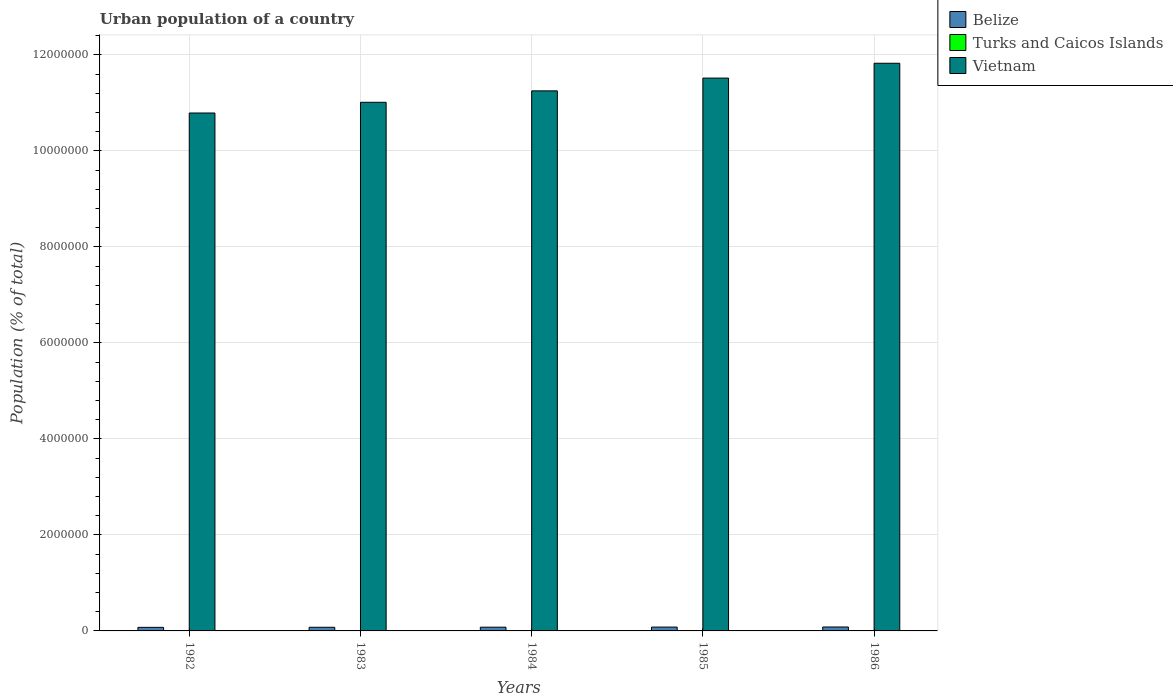How many different coloured bars are there?
Your answer should be compact. 3. How many groups of bars are there?
Provide a short and direct response. 5. Are the number of bars per tick equal to the number of legend labels?
Ensure brevity in your answer.  Yes. In how many cases, is the number of bars for a given year not equal to the number of legend labels?
Your answer should be compact. 0. What is the urban population in Belize in 1986?
Offer a terse response. 8.18e+04. Across all years, what is the maximum urban population in Vietnam?
Your answer should be very brief. 1.18e+07. Across all years, what is the minimum urban population in Turks and Caicos Islands?
Make the answer very short. 4900. In which year was the urban population in Turks and Caicos Islands maximum?
Ensure brevity in your answer.  1986. In which year was the urban population in Belize minimum?
Your answer should be compact. 1982. What is the total urban population in Belize in the graph?
Provide a short and direct response. 3.90e+05. What is the difference between the urban population in Turks and Caicos Islands in 1983 and that in 1986?
Your response must be concise. -1318. What is the difference between the urban population in Belize in 1986 and the urban population in Vietnam in 1983?
Ensure brevity in your answer.  -1.09e+07. What is the average urban population in Vietnam per year?
Your answer should be compact. 1.13e+07. In the year 1982, what is the difference between the urban population in Vietnam and urban population in Belize?
Ensure brevity in your answer.  1.07e+07. In how many years, is the urban population in Belize greater than 11600000 %?
Give a very brief answer. 0. What is the ratio of the urban population in Belize in 1985 to that in 1986?
Make the answer very short. 0.98. What is the difference between the highest and the second highest urban population in Turks and Caicos Islands?
Offer a very short reply. 431. What is the difference between the highest and the lowest urban population in Belize?
Provide a succinct answer. 7558. Is the sum of the urban population in Turks and Caicos Islands in 1984 and 1986 greater than the maximum urban population in Vietnam across all years?
Offer a terse response. No. What does the 1st bar from the left in 1985 represents?
Offer a terse response. Belize. What does the 3rd bar from the right in 1982 represents?
Provide a succinct answer. Belize. How many bars are there?
Make the answer very short. 15. Are all the bars in the graph horizontal?
Make the answer very short. No. How many years are there in the graph?
Make the answer very short. 5. Are the values on the major ticks of Y-axis written in scientific E-notation?
Make the answer very short. No. Does the graph contain grids?
Provide a succinct answer. Yes. How many legend labels are there?
Keep it short and to the point. 3. How are the legend labels stacked?
Provide a short and direct response. Vertical. What is the title of the graph?
Your answer should be very brief. Urban population of a country. Does "Belize" appear as one of the legend labels in the graph?
Make the answer very short. Yes. What is the label or title of the Y-axis?
Make the answer very short. Population (% of total). What is the Population (% of total) of Belize in 1982?
Ensure brevity in your answer.  7.42e+04. What is the Population (% of total) of Turks and Caicos Islands in 1982?
Offer a terse response. 4900. What is the Population (% of total) in Vietnam in 1982?
Offer a terse response. 1.08e+07. What is the Population (% of total) of Belize in 1983?
Your response must be concise. 7.60e+04. What is the Population (% of total) in Turks and Caicos Islands in 1983?
Offer a very short reply. 5331. What is the Population (% of total) of Vietnam in 1983?
Provide a succinct answer. 1.10e+07. What is the Population (% of total) of Belize in 1984?
Keep it short and to the point. 7.79e+04. What is the Population (% of total) of Turks and Caicos Islands in 1984?
Your answer should be compact. 5775. What is the Population (% of total) in Vietnam in 1984?
Ensure brevity in your answer.  1.12e+07. What is the Population (% of total) of Belize in 1985?
Keep it short and to the point. 7.99e+04. What is the Population (% of total) in Turks and Caicos Islands in 1985?
Keep it short and to the point. 6218. What is the Population (% of total) in Vietnam in 1985?
Keep it short and to the point. 1.15e+07. What is the Population (% of total) of Belize in 1986?
Offer a terse response. 8.18e+04. What is the Population (% of total) in Turks and Caicos Islands in 1986?
Offer a very short reply. 6649. What is the Population (% of total) of Vietnam in 1986?
Your answer should be compact. 1.18e+07. Across all years, what is the maximum Population (% of total) in Belize?
Give a very brief answer. 8.18e+04. Across all years, what is the maximum Population (% of total) in Turks and Caicos Islands?
Ensure brevity in your answer.  6649. Across all years, what is the maximum Population (% of total) of Vietnam?
Provide a succinct answer. 1.18e+07. Across all years, what is the minimum Population (% of total) of Belize?
Your response must be concise. 7.42e+04. Across all years, what is the minimum Population (% of total) of Turks and Caicos Islands?
Give a very brief answer. 4900. Across all years, what is the minimum Population (% of total) in Vietnam?
Provide a short and direct response. 1.08e+07. What is the total Population (% of total) in Belize in the graph?
Your answer should be very brief. 3.90e+05. What is the total Population (% of total) of Turks and Caicos Islands in the graph?
Provide a succinct answer. 2.89e+04. What is the total Population (% of total) in Vietnam in the graph?
Provide a succinct answer. 5.64e+07. What is the difference between the Population (% of total) in Belize in 1982 and that in 1983?
Provide a succinct answer. -1820. What is the difference between the Population (% of total) of Turks and Caicos Islands in 1982 and that in 1983?
Offer a terse response. -431. What is the difference between the Population (% of total) in Vietnam in 1982 and that in 1983?
Your response must be concise. -2.23e+05. What is the difference between the Population (% of total) in Belize in 1982 and that in 1984?
Keep it short and to the point. -3720. What is the difference between the Population (% of total) in Turks and Caicos Islands in 1982 and that in 1984?
Ensure brevity in your answer.  -875. What is the difference between the Population (% of total) of Vietnam in 1982 and that in 1984?
Your answer should be compact. -4.61e+05. What is the difference between the Population (% of total) of Belize in 1982 and that in 1985?
Provide a succinct answer. -5629. What is the difference between the Population (% of total) in Turks and Caicos Islands in 1982 and that in 1985?
Provide a short and direct response. -1318. What is the difference between the Population (% of total) in Vietnam in 1982 and that in 1985?
Make the answer very short. -7.27e+05. What is the difference between the Population (% of total) of Belize in 1982 and that in 1986?
Provide a succinct answer. -7558. What is the difference between the Population (% of total) in Turks and Caicos Islands in 1982 and that in 1986?
Keep it short and to the point. -1749. What is the difference between the Population (% of total) in Vietnam in 1982 and that in 1986?
Provide a short and direct response. -1.04e+06. What is the difference between the Population (% of total) in Belize in 1983 and that in 1984?
Ensure brevity in your answer.  -1900. What is the difference between the Population (% of total) of Turks and Caicos Islands in 1983 and that in 1984?
Offer a terse response. -444. What is the difference between the Population (% of total) of Vietnam in 1983 and that in 1984?
Provide a succinct answer. -2.38e+05. What is the difference between the Population (% of total) in Belize in 1983 and that in 1985?
Your response must be concise. -3809. What is the difference between the Population (% of total) of Turks and Caicos Islands in 1983 and that in 1985?
Offer a terse response. -887. What is the difference between the Population (% of total) in Vietnam in 1983 and that in 1985?
Make the answer very short. -5.04e+05. What is the difference between the Population (% of total) in Belize in 1983 and that in 1986?
Provide a short and direct response. -5738. What is the difference between the Population (% of total) of Turks and Caicos Islands in 1983 and that in 1986?
Provide a short and direct response. -1318. What is the difference between the Population (% of total) in Vietnam in 1983 and that in 1986?
Provide a succinct answer. -8.13e+05. What is the difference between the Population (% of total) of Belize in 1984 and that in 1985?
Offer a very short reply. -1909. What is the difference between the Population (% of total) of Turks and Caicos Islands in 1984 and that in 1985?
Make the answer very short. -443. What is the difference between the Population (% of total) of Vietnam in 1984 and that in 1985?
Your answer should be very brief. -2.66e+05. What is the difference between the Population (% of total) of Belize in 1984 and that in 1986?
Give a very brief answer. -3838. What is the difference between the Population (% of total) in Turks and Caicos Islands in 1984 and that in 1986?
Provide a short and direct response. -874. What is the difference between the Population (% of total) in Vietnam in 1984 and that in 1986?
Keep it short and to the point. -5.75e+05. What is the difference between the Population (% of total) of Belize in 1985 and that in 1986?
Ensure brevity in your answer.  -1929. What is the difference between the Population (% of total) in Turks and Caicos Islands in 1985 and that in 1986?
Make the answer very short. -431. What is the difference between the Population (% of total) of Vietnam in 1985 and that in 1986?
Your answer should be compact. -3.09e+05. What is the difference between the Population (% of total) in Belize in 1982 and the Population (% of total) in Turks and Caicos Islands in 1983?
Make the answer very short. 6.89e+04. What is the difference between the Population (% of total) of Belize in 1982 and the Population (% of total) of Vietnam in 1983?
Provide a succinct answer. -1.09e+07. What is the difference between the Population (% of total) of Turks and Caicos Islands in 1982 and the Population (% of total) of Vietnam in 1983?
Your response must be concise. -1.10e+07. What is the difference between the Population (% of total) of Belize in 1982 and the Population (% of total) of Turks and Caicos Islands in 1984?
Make the answer very short. 6.84e+04. What is the difference between the Population (% of total) of Belize in 1982 and the Population (% of total) of Vietnam in 1984?
Give a very brief answer. -1.12e+07. What is the difference between the Population (% of total) of Turks and Caicos Islands in 1982 and the Population (% of total) of Vietnam in 1984?
Your response must be concise. -1.12e+07. What is the difference between the Population (% of total) of Belize in 1982 and the Population (% of total) of Turks and Caicos Islands in 1985?
Provide a short and direct response. 6.80e+04. What is the difference between the Population (% of total) of Belize in 1982 and the Population (% of total) of Vietnam in 1985?
Your response must be concise. -1.14e+07. What is the difference between the Population (% of total) in Turks and Caicos Islands in 1982 and the Population (% of total) in Vietnam in 1985?
Provide a short and direct response. -1.15e+07. What is the difference between the Population (% of total) of Belize in 1982 and the Population (% of total) of Turks and Caicos Islands in 1986?
Your response must be concise. 6.76e+04. What is the difference between the Population (% of total) in Belize in 1982 and the Population (% of total) in Vietnam in 1986?
Ensure brevity in your answer.  -1.17e+07. What is the difference between the Population (% of total) in Turks and Caicos Islands in 1982 and the Population (% of total) in Vietnam in 1986?
Your response must be concise. -1.18e+07. What is the difference between the Population (% of total) in Belize in 1983 and the Population (% of total) in Turks and Caicos Islands in 1984?
Your response must be concise. 7.03e+04. What is the difference between the Population (% of total) of Belize in 1983 and the Population (% of total) of Vietnam in 1984?
Make the answer very short. -1.12e+07. What is the difference between the Population (% of total) of Turks and Caicos Islands in 1983 and the Population (% of total) of Vietnam in 1984?
Make the answer very short. -1.12e+07. What is the difference between the Population (% of total) in Belize in 1983 and the Population (% of total) in Turks and Caicos Islands in 1985?
Ensure brevity in your answer.  6.98e+04. What is the difference between the Population (% of total) of Belize in 1983 and the Population (% of total) of Vietnam in 1985?
Provide a succinct answer. -1.14e+07. What is the difference between the Population (% of total) of Turks and Caicos Islands in 1983 and the Population (% of total) of Vietnam in 1985?
Give a very brief answer. -1.15e+07. What is the difference between the Population (% of total) of Belize in 1983 and the Population (% of total) of Turks and Caicos Islands in 1986?
Give a very brief answer. 6.94e+04. What is the difference between the Population (% of total) in Belize in 1983 and the Population (% of total) in Vietnam in 1986?
Your answer should be very brief. -1.17e+07. What is the difference between the Population (% of total) of Turks and Caicos Islands in 1983 and the Population (% of total) of Vietnam in 1986?
Your answer should be compact. -1.18e+07. What is the difference between the Population (% of total) of Belize in 1984 and the Population (% of total) of Turks and Caicos Islands in 1985?
Ensure brevity in your answer.  7.17e+04. What is the difference between the Population (% of total) of Belize in 1984 and the Population (% of total) of Vietnam in 1985?
Offer a very short reply. -1.14e+07. What is the difference between the Population (% of total) of Turks and Caicos Islands in 1984 and the Population (% of total) of Vietnam in 1985?
Offer a very short reply. -1.15e+07. What is the difference between the Population (% of total) of Belize in 1984 and the Population (% of total) of Turks and Caicos Islands in 1986?
Give a very brief answer. 7.13e+04. What is the difference between the Population (% of total) in Belize in 1984 and the Population (% of total) in Vietnam in 1986?
Offer a terse response. -1.17e+07. What is the difference between the Population (% of total) in Turks and Caicos Islands in 1984 and the Population (% of total) in Vietnam in 1986?
Your answer should be very brief. -1.18e+07. What is the difference between the Population (% of total) in Belize in 1985 and the Population (% of total) in Turks and Caicos Islands in 1986?
Make the answer very short. 7.32e+04. What is the difference between the Population (% of total) of Belize in 1985 and the Population (% of total) of Vietnam in 1986?
Give a very brief answer. -1.17e+07. What is the difference between the Population (% of total) in Turks and Caicos Islands in 1985 and the Population (% of total) in Vietnam in 1986?
Keep it short and to the point. -1.18e+07. What is the average Population (% of total) of Belize per year?
Provide a short and direct response. 7.80e+04. What is the average Population (% of total) in Turks and Caicos Islands per year?
Provide a succinct answer. 5774.6. What is the average Population (% of total) of Vietnam per year?
Give a very brief answer. 1.13e+07. In the year 1982, what is the difference between the Population (% of total) in Belize and Population (% of total) in Turks and Caicos Islands?
Ensure brevity in your answer.  6.93e+04. In the year 1982, what is the difference between the Population (% of total) in Belize and Population (% of total) in Vietnam?
Offer a very short reply. -1.07e+07. In the year 1982, what is the difference between the Population (% of total) in Turks and Caicos Islands and Population (% of total) in Vietnam?
Provide a short and direct response. -1.08e+07. In the year 1983, what is the difference between the Population (% of total) in Belize and Population (% of total) in Turks and Caicos Islands?
Make the answer very short. 7.07e+04. In the year 1983, what is the difference between the Population (% of total) in Belize and Population (% of total) in Vietnam?
Your answer should be very brief. -1.09e+07. In the year 1983, what is the difference between the Population (% of total) in Turks and Caicos Islands and Population (% of total) in Vietnam?
Provide a succinct answer. -1.10e+07. In the year 1984, what is the difference between the Population (% of total) in Belize and Population (% of total) in Turks and Caicos Islands?
Provide a short and direct response. 7.22e+04. In the year 1984, what is the difference between the Population (% of total) in Belize and Population (% of total) in Vietnam?
Your answer should be compact. -1.12e+07. In the year 1984, what is the difference between the Population (% of total) of Turks and Caicos Islands and Population (% of total) of Vietnam?
Ensure brevity in your answer.  -1.12e+07. In the year 1985, what is the difference between the Population (% of total) in Belize and Population (% of total) in Turks and Caicos Islands?
Ensure brevity in your answer.  7.36e+04. In the year 1985, what is the difference between the Population (% of total) in Belize and Population (% of total) in Vietnam?
Give a very brief answer. -1.14e+07. In the year 1985, what is the difference between the Population (% of total) in Turks and Caicos Islands and Population (% of total) in Vietnam?
Provide a succinct answer. -1.15e+07. In the year 1986, what is the difference between the Population (% of total) of Belize and Population (% of total) of Turks and Caicos Islands?
Ensure brevity in your answer.  7.51e+04. In the year 1986, what is the difference between the Population (% of total) in Belize and Population (% of total) in Vietnam?
Your answer should be very brief. -1.17e+07. In the year 1986, what is the difference between the Population (% of total) of Turks and Caicos Islands and Population (% of total) of Vietnam?
Ensure brevity in your answer.  -1.18e+07. What is the ratio of the Population (% of total) of Belize in 1982 to that in 1983?
Provide a short and direct response. 0.98. What is the ratio of the Population (% of total) of Turks and Caicos Islands in 1982 to that in 1983?
Your answer should be compact. 0.92. What is the ratio of the Population (% of total) in Vietnam in 1982 to that in 1983?
Your response must be concise. 0.98. What is the ratio of the Population (% of total) in Belize in 1982 to that in 1984?
Your response must be concise. 0.95. What is the ratio of the Population (% of total) of Turks and Caicos Islands in 1982 to that in 1984?
Offer a terse response. 0.85. What is the ratio of the Population (% of total) in Vietnam in 1982 to that in 1984?
Make the answer very short. 0.96. What is the ratio of the Population (% of total) of Belize in 1982 to that in 1985?
Keep it short and to the point. 0.93. What is the ratio of the Population (% of total) in Turks and Caicos Islands in 1982 to that in 1985?
Your answer should be compact. 0.79. What is the ratio of the Population (% of total) of Vietnam in 1982 to that in 1985?
Your answer should be very brief. 0.94. What is the ratio of the Population (% of total) in Belize in 1982 to that in 1986?
Make the answer very short. 0.91. What is the ratio of the Population (% of total) in Turks and Caicos Islands in 1982 to that in 1986?
Make the answer very short. 0.74. What is the ratio of the Population (% of total) in Vietnam in 1982 to that in 1986?
Offer a terse response. 0.91. What is the ratio of the Population (% of total) of Belize in 1983 to that in 1984?
Keep it short and to the point. 0.98. What is the ratio of the Population (% of total) of Vietnam in 1983 to that in 1984?
Give a very brief answer. 0.98. What is the ratio of the Population (% of total) of Belize in 1983 to that in 1985?
Offer a very short reply. 0.95. What is the ratio of the Population (% of total) in Turks and Caicos Islands in 1983 to that in 1985?
Give a very brief answer. 0.86. What is the ratio of the Population (% of total) in Vietnam in 1983 to that in 1985?
Offer a very short reply. 0.96. What is the ratio of the Population (% of total) in Belize in 1983 to that in 1986?
Give a very brief answer. 0.93. What is the ratio of the Population (% of total) in Turks and Caicos Islands in 1983 to that in 1986?
Provide a short and direct response. 0.8. What is the ratio of the Population (% of total) in Vietnam in 1983 to that in 1986?
Your answer should be compact. 0.93. What is the ratio of the Population (% of total) of Belize in 1984 to that in 1985?
Provide a succinct answer. 0.98. What is the ratio of the Population (% of total) in Turks and Caicos Islands in 1984 to that in 1985?
Give a very brief answer. 0.93. What is the ratio of the Population (% of total) in Vietnam in 1984 to that in 1985?
Your response must be concise. 0.98. What is the ratio of the Population (% of total) in Belize in 1984 to that in 1986?
Your response must be concise. 0.95. What is the ratio of the Population (% of total) in Turks and Caicos Islands in 1984 to that in 1986?
Offer a terse response. 0.87. What is the ratio of the Population (% of total) in Vietnam in 1984 to that in 1986?
Provide a short and direct response. 0.95. What is the ratio of the Population (% of total) of Belize in 1985 to that in 1986?
Your answer should be compact. 0.98. What is the ratio of the Population (% of total) in Turks and Caicos Islands in 1985 to that in 1986?
Offer a terse response. 0.94. What is the ratio of the Population (% of total) of Vietnam in 1985 to that in 1986?
Give a very brief answer. 0.97. What is the difference between the highest and the second highest Population (% of total) in Belize?
Provide a short and direct response. 1929. What is the difference between the highest and the second highest Population (% of total) of Turks and Caicos Islands?
Give a very brief answer. 431. What is the difference between the highest and the second highest Population (% of total) in Vietnam?
Make the answer very short. 3.09e+05. What is the difference between the highest and the lowest Population (% of total) of Belize?
Offer a very short reply. 7558. What is the difference between the highest and the lowest Population (% of total) in Turks and Caicos Islands?
Provide a succinct answer. 1749. What is the difference between the highest and the lowest Population (% of total) in Vietnam?
Offer a terse response. 1.04e+06. 